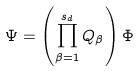Convert formula to latex. <formula><loc_0><loc_0><loc_500><loc_500>\Psi = \left ( \prod ^ { s _ { d } } _ { \beta = 1 } Q _ { \beta } \right ) \Phi</formula> 